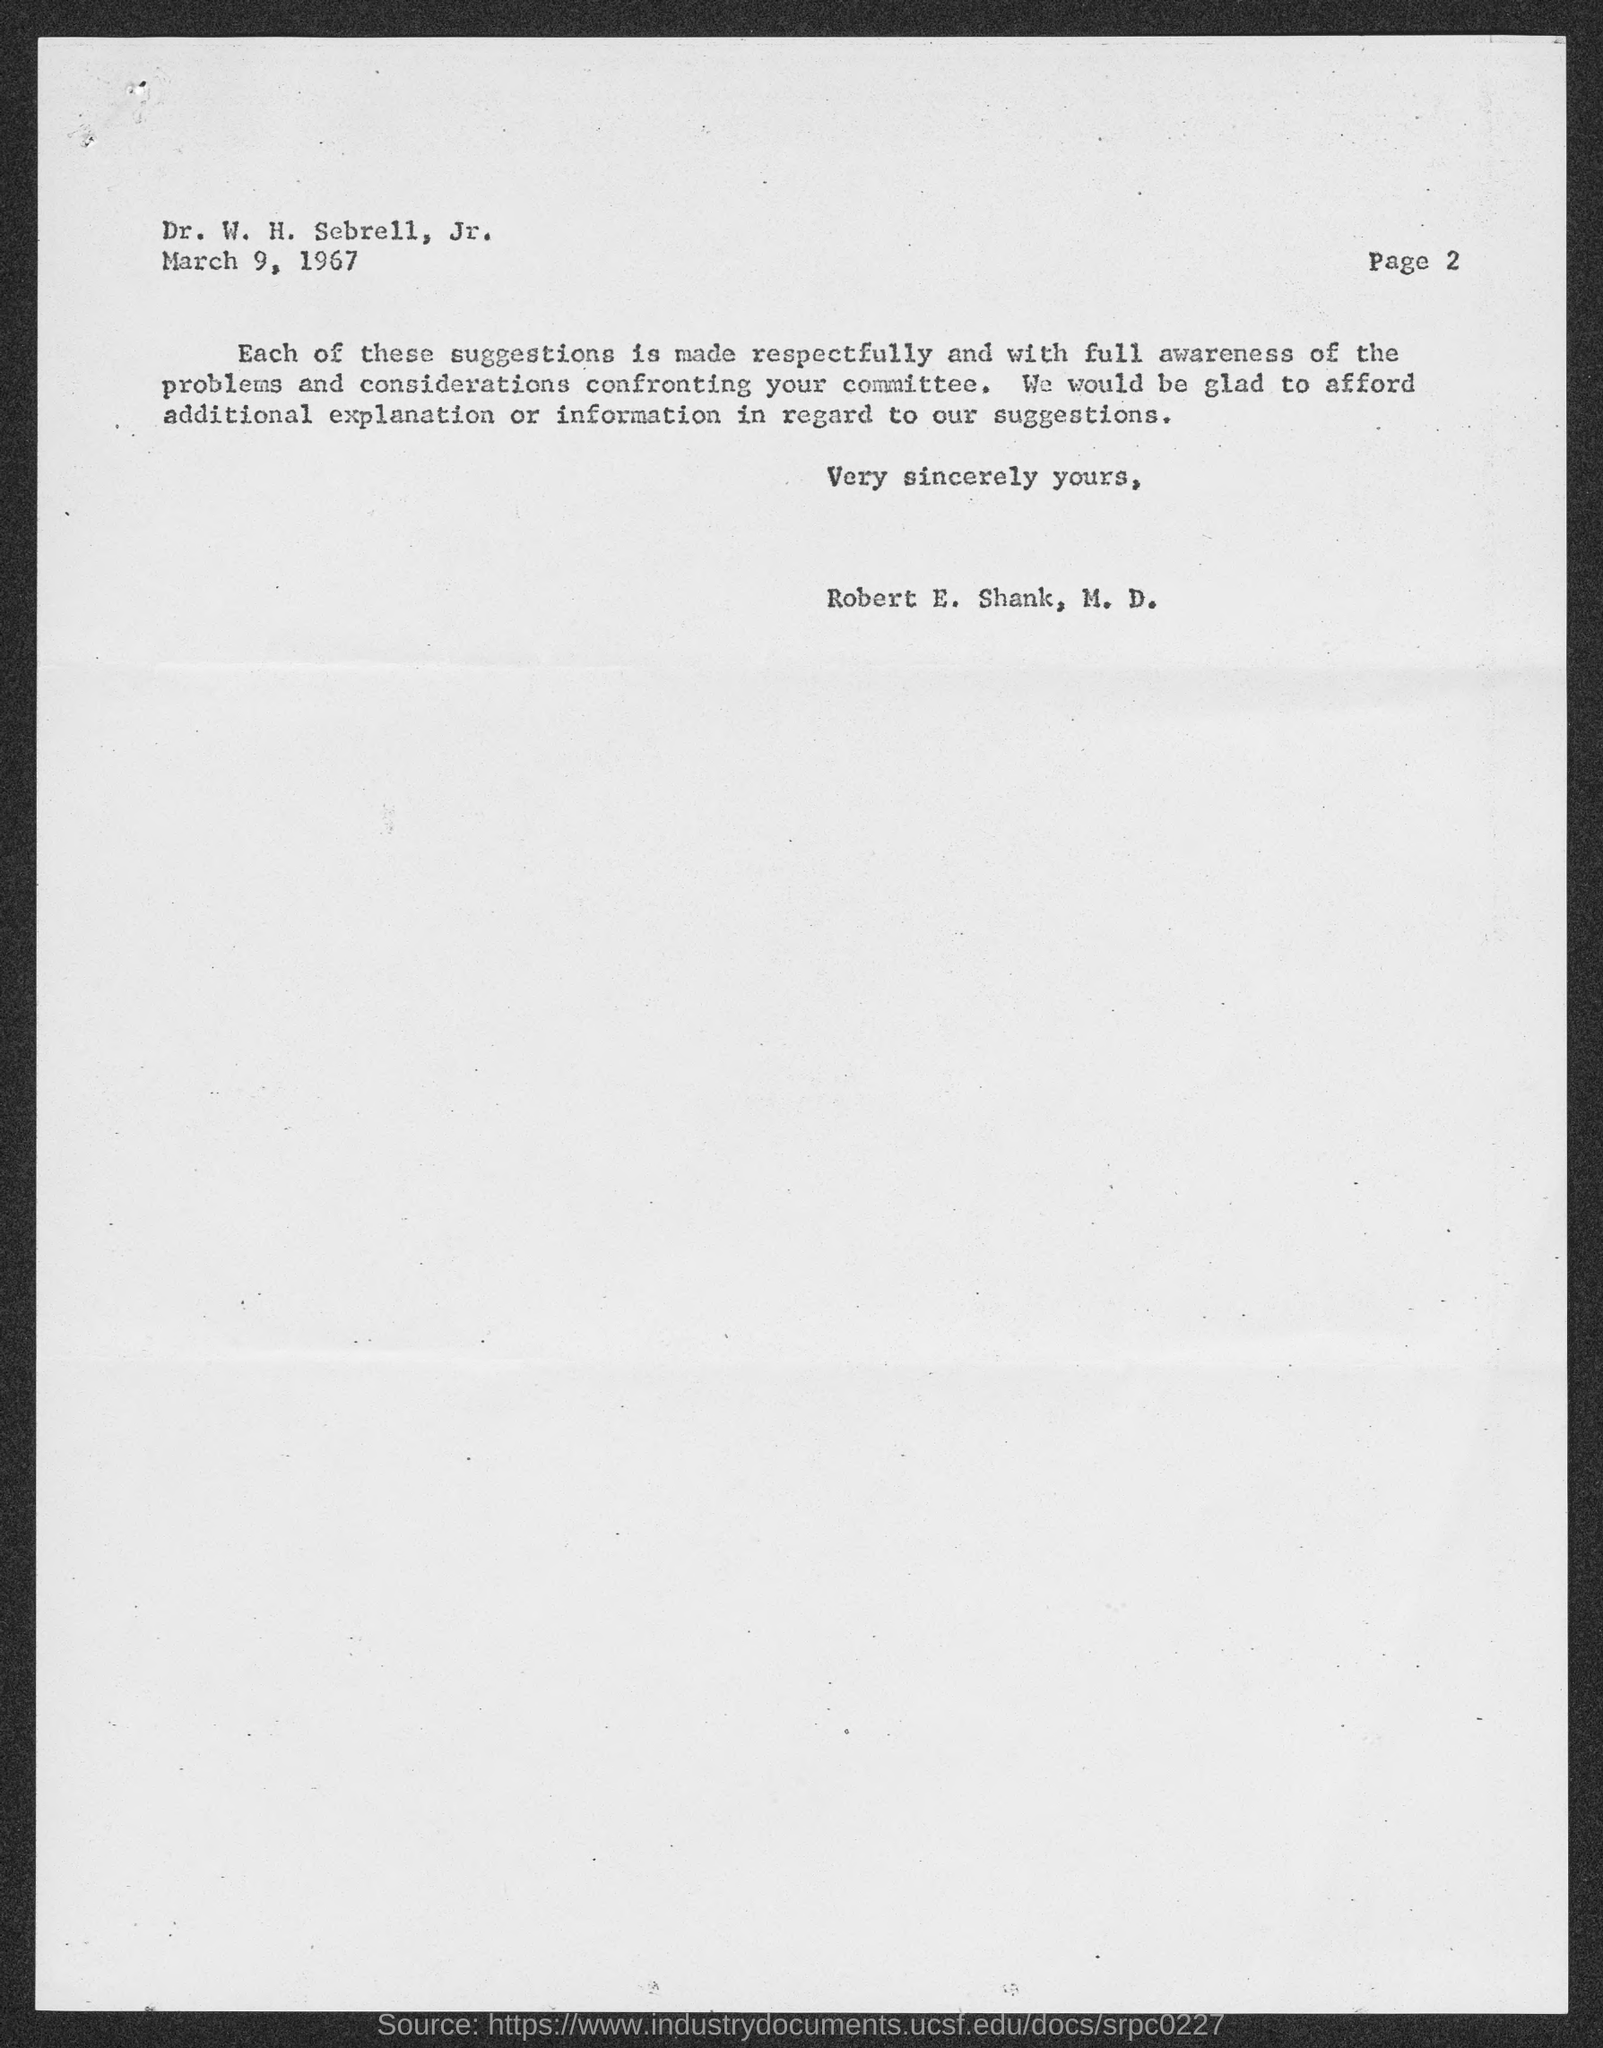Specify some key components in this picture. The page number written in the document is 2. The memorandum was dated March 9, 1967. 